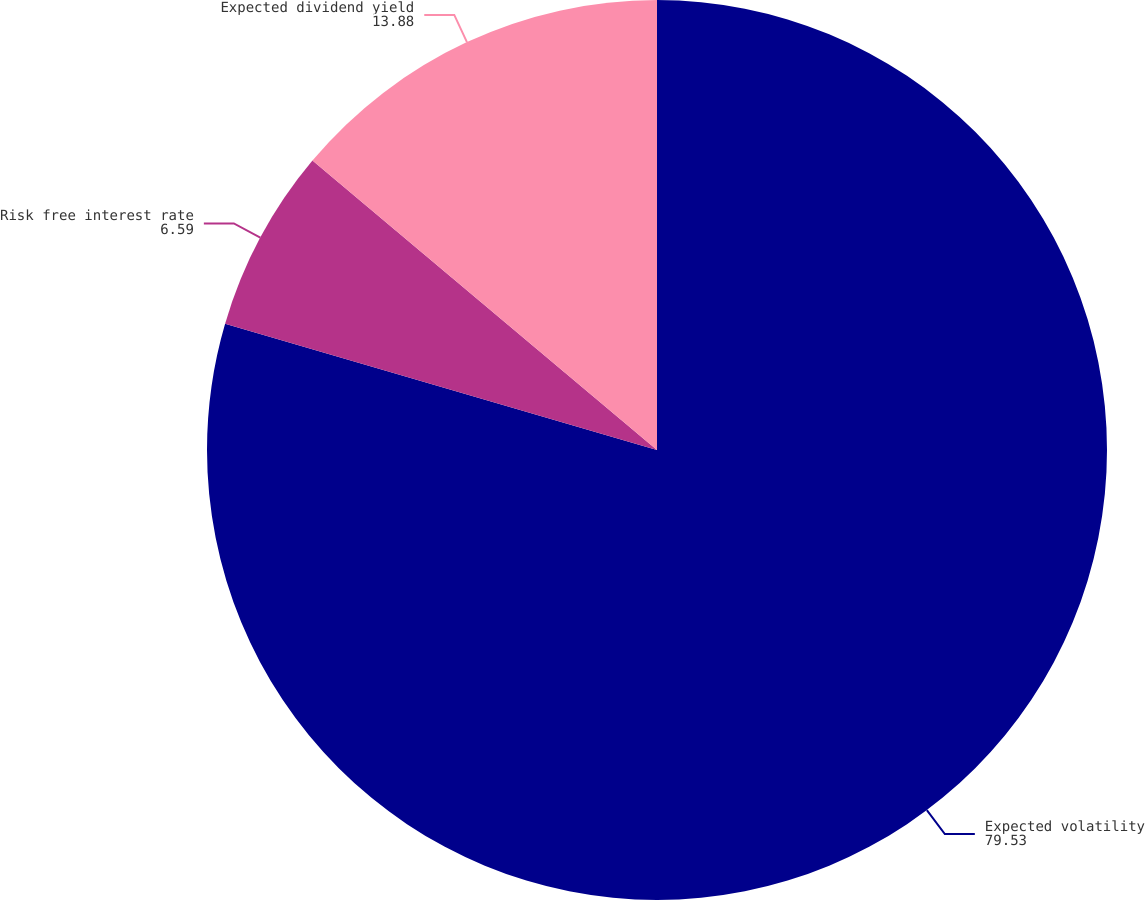Convert chart to OTSL. <chart><loc_0><loc_0><loc_500><loc_500><pie_chart><fcel>Expected volatility<fcel>Risk free interest rate<fcel>Expected dividend yield<nl><fcel>79.53%<fcel>6.59%<fcel>13.88%<nl></chart> 